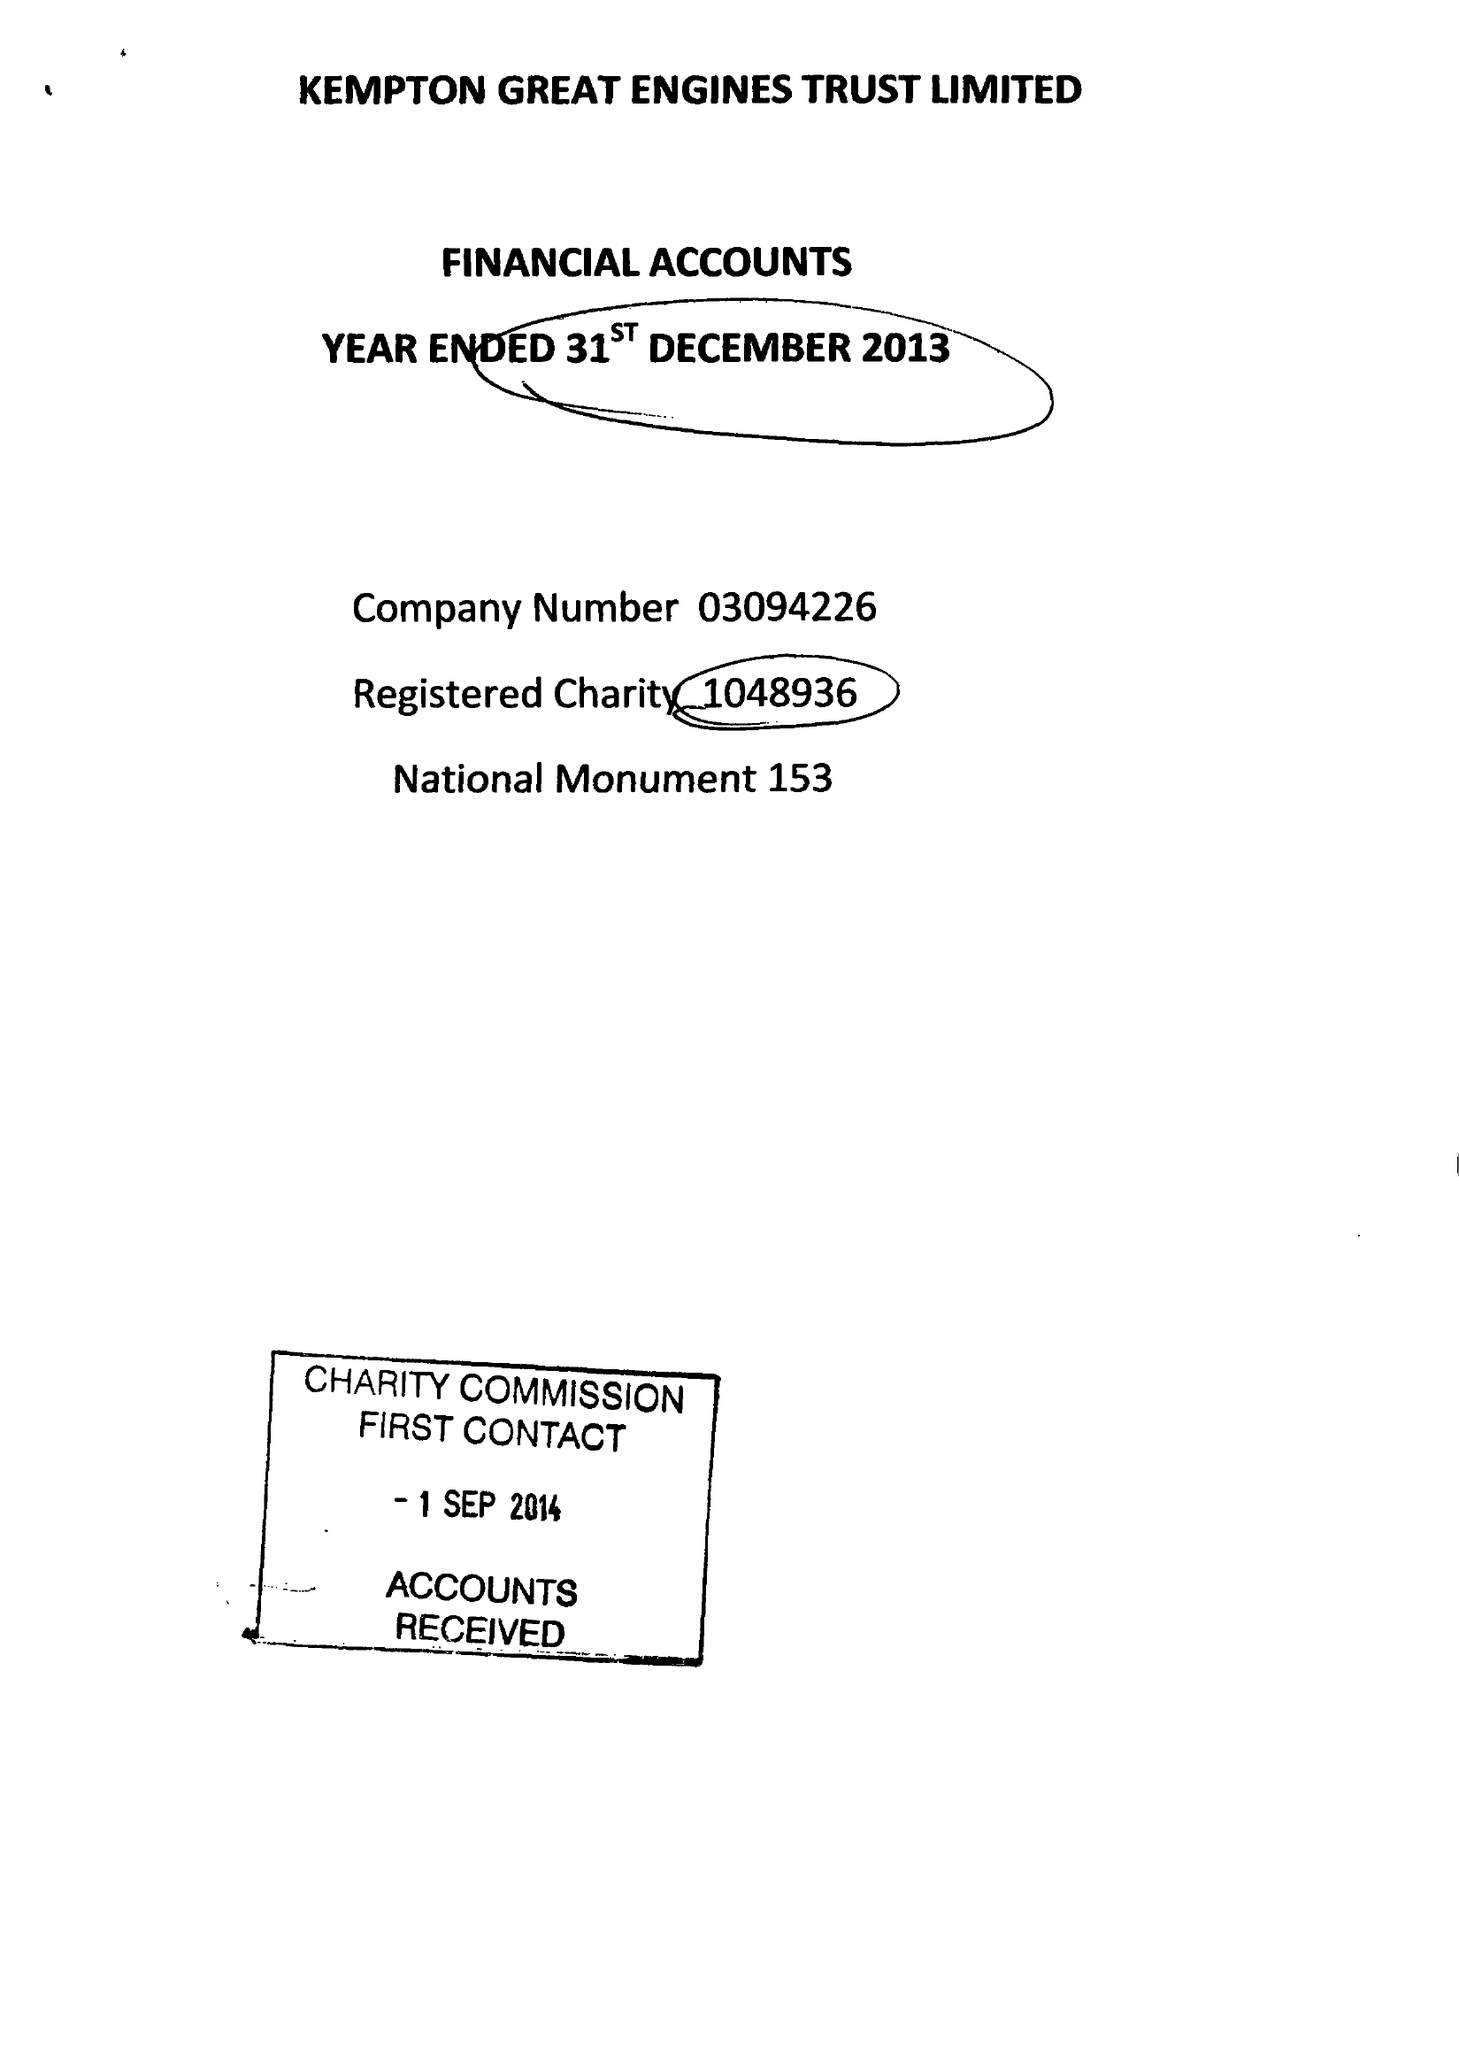What is the value for the address__postcode?
Answer the question using a single word or phrase. TW13 6XH 